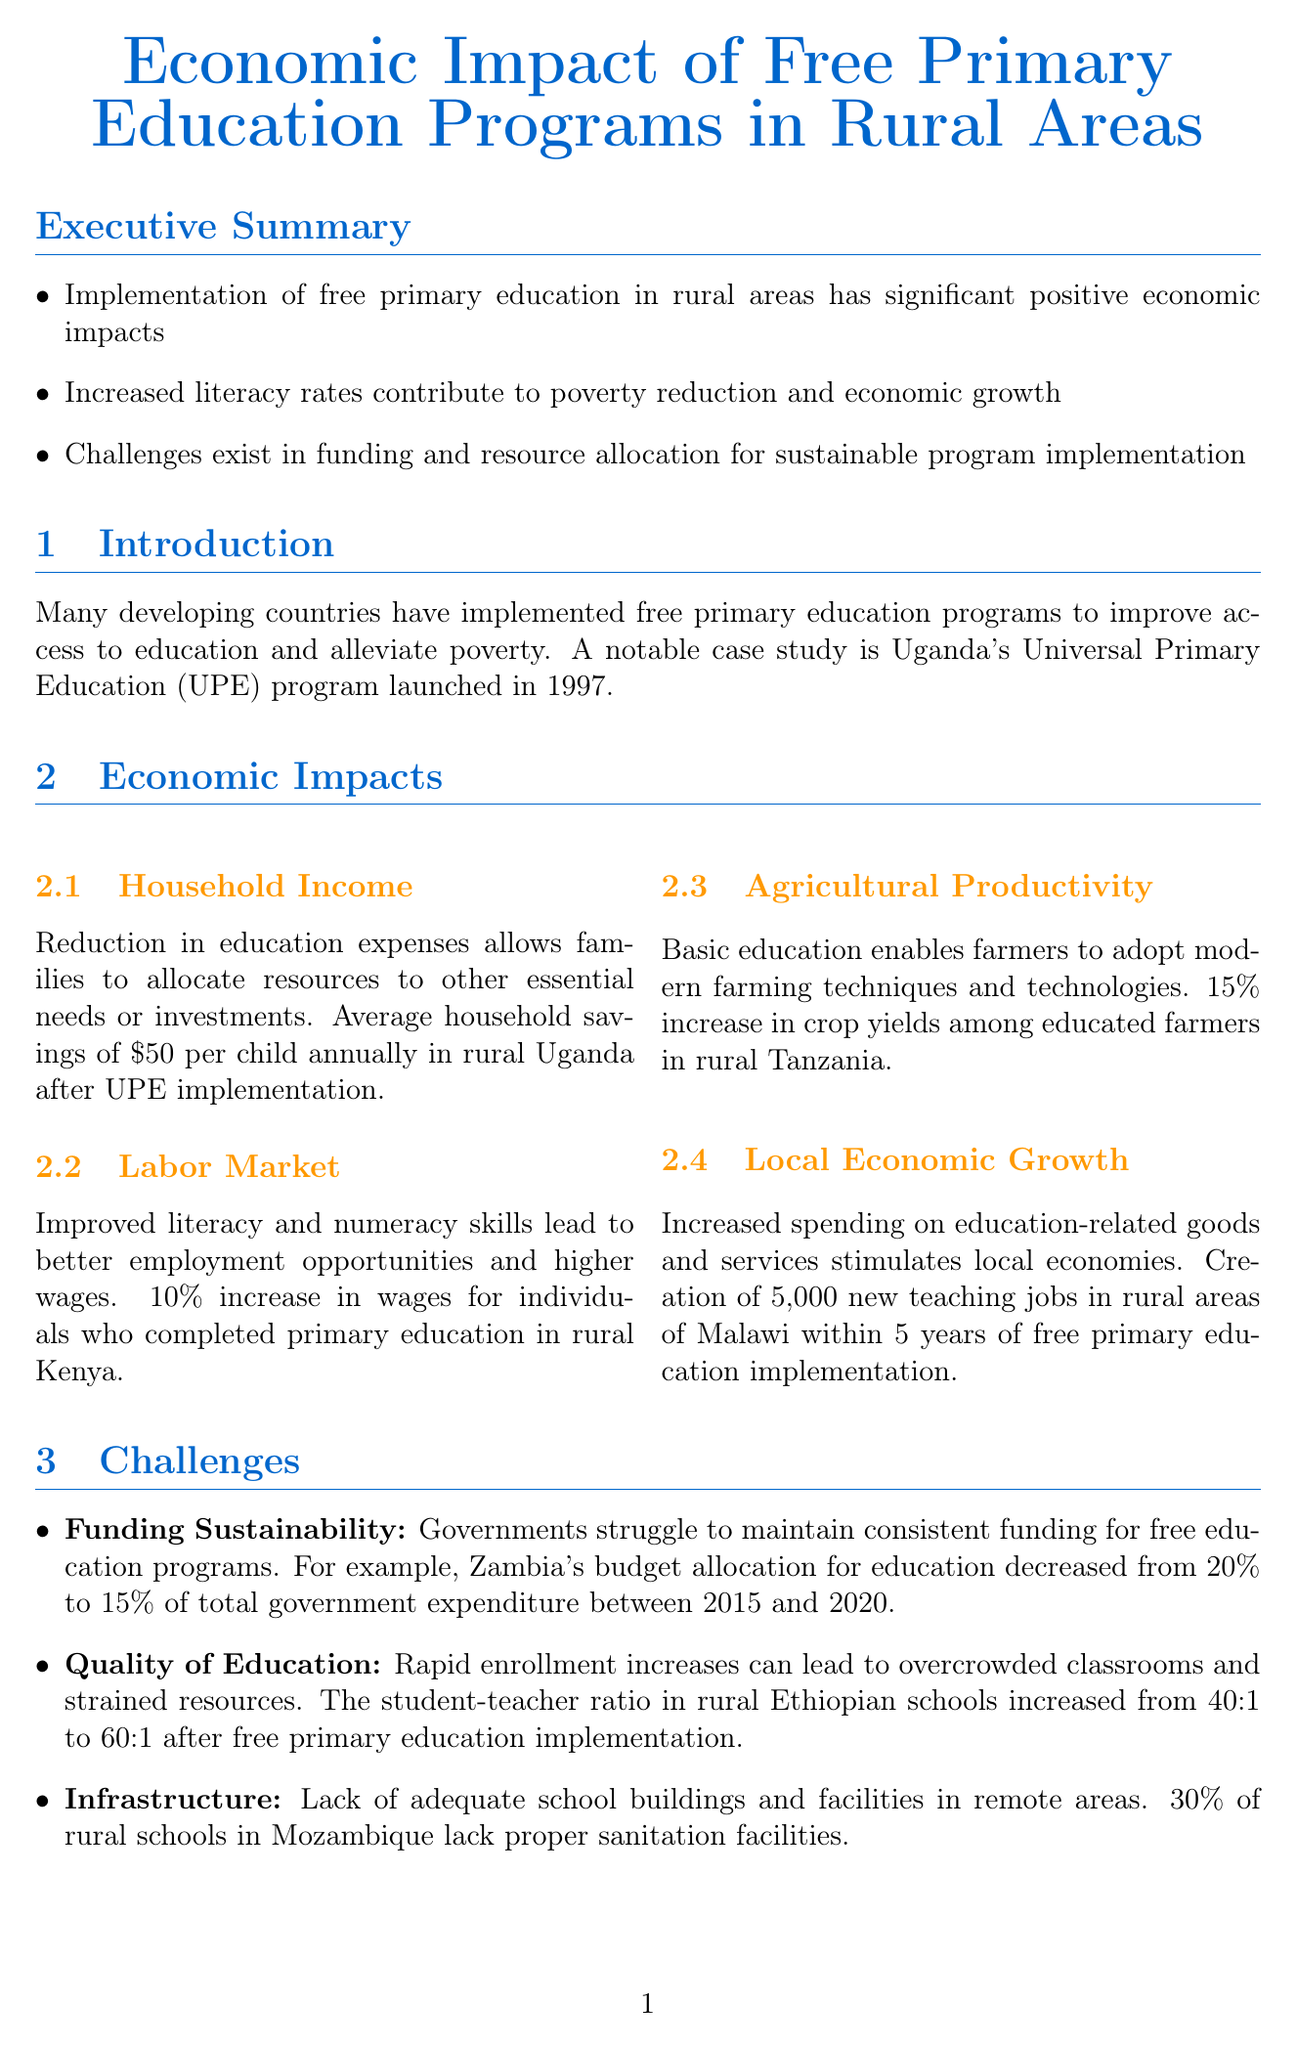What is the title of the report? The title of the report is stated at the beginning of the document, which is focused on free primary education.
Answer: Economic Impact of Free Primary Education Programs in Rural Areas What is the average household savings per child annually in rural Uganda after UPE implementation? This statistic is included in the economic impacts section and highlights financial benefits for families.
Answer: $50 What year was Uganda's Universal Primary Education (UPE) program launched? The introduction provides specific information about the case study and its launch year.
Answer: 1997 What percentage of Zambia's budget allocation for education decreased between 2015 and 2020? This statistic can be found in the challenges section regarding funding sustainability.
Answer: 5% How much did wages increase for individuals who completed primary education in rural Kenya? The economic impacts section details labor market improvements and states this percentage increase.
Answer: 10% What type of partnerships is suggested to improve funding and management of educational infrastructure? The recommendations section suggests a specific approach to enhancing education quality and resources through collaboration.
Answer: Public-Private Partnerships What is the student-teacher ratio increase in rural Ethiopian schools after free primary education implementation? This specific information is provided in the challenges section and reflects on education quality issues.
Answer: 20:1 Which organization is mentioned as working alongside the Liberian government in school management? This is given as an example of community involvement in the recommendations section.
Answer: Bridge International Academies What is the percentage increase in crop yields among educated farmers in rural Tanzania? This statistic is noted in the economic impacts section related to agricultural productivity.
Answer: 15% 